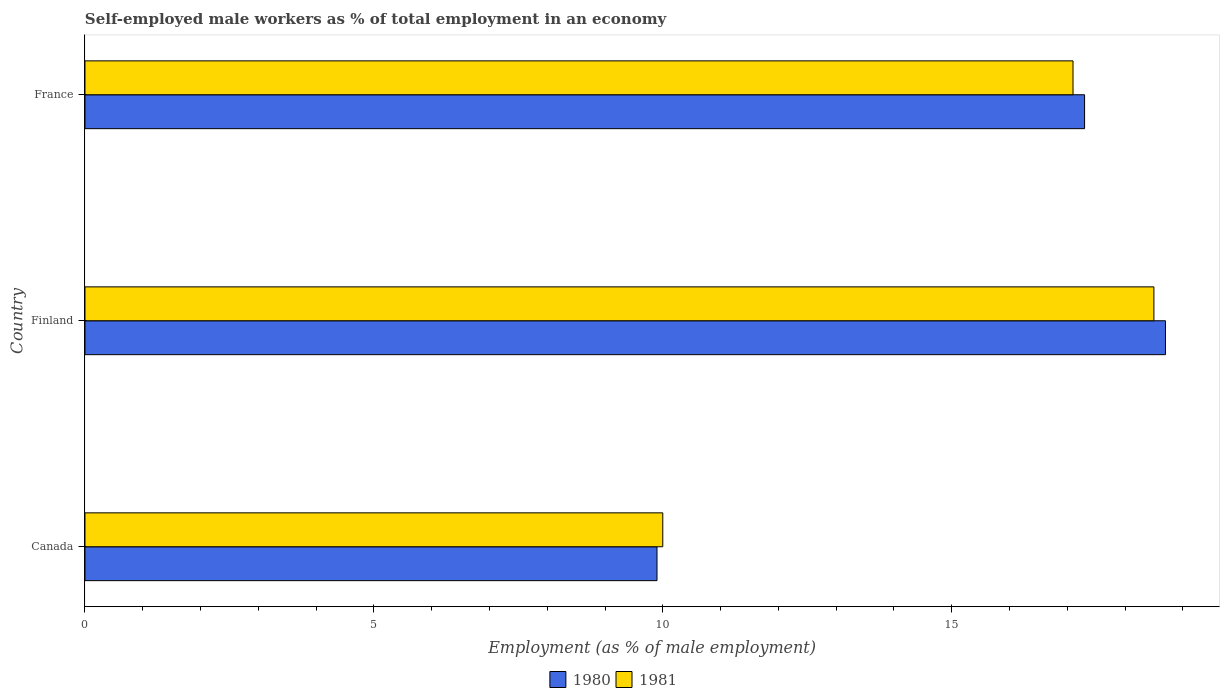How many different coloured bars are there?
Offer a very short reply. 2. Are the number of bars per tick equal to the number of legend labels?
Give a very brief answer. Yes. How many bars are there on the 2nd tick from the top?
Keep it short and to the point. 2. How many bars are there on the 2nd tick from the bottom?
Your response must be concise. 2. In how many cases, is the number of bars for a given country not equal to the number of legend labels?
Make the answer very short. 0. What is the percentage of self-employed male workers in 1980 in Canada?
Offer a very short reply. 9.9. Across all countries, what is the minimum percentage of self-employed male workers in 1981?
Provide a succinct answer. 10. In which country was the percentage of self-employed male workers in 1980 maximum?
Your answer should be compact. Finland. In which country was the percentage of self-employed male workers in 1980 minimum?
Provide a succinct answer. Canada. What is the total percentage of self-employed male workers in 1981 in the graph?
Your answer should be compact. 45.6. What is the difference between the percentage of self-employed male workers in 1980 in Finland and that in France?
Provide a succinct answer. 1.4. What is the difference between the percentage of self-employed male workers in 1981 in Finland and the percentage of self-employed male workers in 1980 in Canada?
Keep it short and to the point. 8.6. What is the average percentage of self-employed male workers in 1981 per country?
Offer a very short reply. 15.2. What is the difference between the percentage of self-employed male workers in 1981 and percentage of self-employed male workers in 1980 in France?
Ensure brevity in your answer.  -0.2. What is the ratio of the percentage of self-employed male workers in 1981 in Canada to that in France?
Offer a terse response. 0.58. Is the percentage of self-employed male workers in 1981 in Canada less than that in France?
Make the answer very short. Yes. Is the difference between the percentage of self-employed male workers in 1981 in Finland and France greater than the difference between the percentage of self-employed male workers in 1980 in Finland and France?
Ensure brevity in your answer.  No. What is the difference between the highest and the second highest percentage of self-employed male workers in 1980?
Keep it short and to the point. 1.4. What is the difference between the highest and the lowest percentage of self-employed male workers in 1981?
Keep it short and to the point. 8.5. Is the sum of the percentage of self-employed male workers in 1980 in Canada and France greater than the maximum percentage of self-employed male workers in 1981 across all countries?
Make the answer very short. Yes. What does the 1st bar from the top in Finland represents?
Provide a succinct answer. 1981. What does the 1st bar from the bottom in Canada represents?
Make the answer very short. 1980. How many bars are there?
Offer a terse response. 6. Are all the bars in the graph horizontal?
Keep it short and to the point. Yes. How many countries are there in the graph?
Your answer should be very brief. 3. Are the values on the major ticks of X-axis written in scientific E-notation?
Your answer should be very brief. No. Does the graph contain any zero values?
Your answer should be very brief. No. Where does the legend appear in the graph?
Your answer should be compact. Bottom center. How are the legend labels stacked?
Ensure brevity in your answer.  Horizontal. What is the title of the graph?
Keep it short and to the point. Self-employed male workers as % of total employment in an economy. What is the label or title of the X-axis?
Offer a very short reply. Employment (as % of male employment). What is the Employment (as % of male employment) in 1980 in Canada?
Your response must be concise. 9.9. What is the Employment (as % of male employment) of 1981 in Canada?
Make the answer very short. 10. What is the Employment (as % of male employment) in 1980 in Finland?
Make the answer very short. 18.7. What is the Employment (as % of male employment) of 1981 in Finland?
Make the answer very short. 18.5. What is the Employment (as % of male employment) of 1980 in France?
Offer a terse response. 17.3. What is the Employment (as % of male employment) of 1981 in France?
Your answer should be very brief. 17.1. Across all countries, what is the maximum Employment (as % of male employment) of 1980?
Offer a very short reply. 18.7. Across all countries, what is the maximum Employment (as % of male employment) of 1981?
Your response must be concise. 18.5. Across all countries, what is the minimum Employment (as % of male employment) in 1980?
Provide a succinct answer. 9.9. Across all countries, what is the minimum Employment (as % of male employment) in 1981?
Provide a succinct answer. 10. What is the total Employment (as % of male employment) in 1980 in the graph?
Offer a very short reply. 45.9. What is the total Employment (as % of male employment) in 1981 in the graph?
Provide a short and direct response. 45.6. What is the difference between the Employment (as % of male employment) of 1980 in Canada and that in Finland?
Your response must be concise. -8.8. What is the difference between the Employment (as % of male employment) in 1980 in Canada and that in France?
Provide a short and direct response. -7.4. What is the difference between the Employment (as % of male employment) of 1981 in Canada and that in France?
Your answer should be very brief. -7.1. What is the difference between the Employment (as % of male employment) of 1980 in Finland and that in France?
Your answer should be very brief. 1.4. What is the difference between the Employment (as % of male employment) in 1981 in Finland and that in France?
Your answer should be compact. 1.4. What is the difference between the Employment (as % of male employment) in 1980 in Canada and the Employment (as % of male employment) in 1981 in Finland?
Make the answer very short. -8.6. What is the difference between the Employment (as % of male employment) in 1980 in Canada and the Employment (as % of male employment) in 1981 in France?
Provide a succinct answer. -7.2. What is the difference between the Employment (as % of male employment) of 1980 in Finland and the Employment (as % of male employment) of 1981 in France?
Provide a succinct answer. 1.6. What is the average Employment (as % of male employment) in 1981 per country?
Offer a terse response. 15.2. What is the difference between the Employment (as % of male employment) of 1980 and Employment (as % of male employment) of 1981 in Finland?
Give a very brief answer. 0.2. What is the ratio of the Employment (as % of male employment) of 1980 in Canada to that in Finland?
Keep it short and to the point. 0.53. What is the ratio of the Employment (as % of male employment) of 1981 in Canada to that in Finland?
Keep it short and to the point. 0.54. What is the ratio of the Employment (as % of male employment) in 1980 in Canada to that in France?
Ensure brevity in your answer.  0.57. What is the ratio of the Employment (as % of male employment) in 1981 in Canada to that in France?
Give a very brief answer. 0.58. What is the ratio of the Employment (as % of male employment) in 1980 in Finland to that in France?
Offer a very short reply. 1.08. What is the ratio of the Employment (as % of male employment) of 1981 in Finland to that in France?
Offer a very short reply. 1.08. What is the difference between the highest and the lowest Employment (as % of male employment) of 1981?
Make the answer very short. 8.5. 